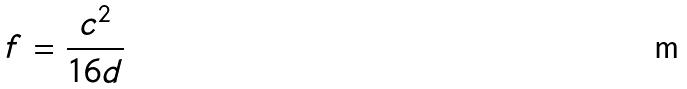Convert formula to latex. <formula><loc_0><loc_0><loc_500><loc_500>f = \frac { c ^ { 2 } } { 1 6 d }</formula> 